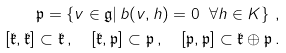<formula> <loc_0><loc_0><loc_500><loc_500>\mathfrak { p } = \left \{ v \in \mathfrak { g } | \, b ( v , h ) = 0 \ \forall h \in K \right \} \, , \\ \left [ \mathfrak { k } , \mathfrak { k } \right ] \subset \mathfrak { k } \, , \quad \left [ \mathfrak { k } , \mathfrak { p } \right ] \subset \mathfrak { p } \, , \quad \left [ \mathfrak { p } , \mathfrak { p } \right ] \subset \mathfrak { k } \oplus \mathfrak { p } \, .</formula> 